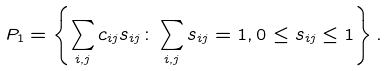Convert formula to latex. <formula><loc_0><loc_0><loc_500><loc_500>P _ { 1 } = \left \{ \sum _ { i , j } c _ { i j } s _ { i j } \colon \sum _ { i , j } s _ { i j } = 1 , 0 \leq s _ { i j } \leq 1 \right \} .</formula> 